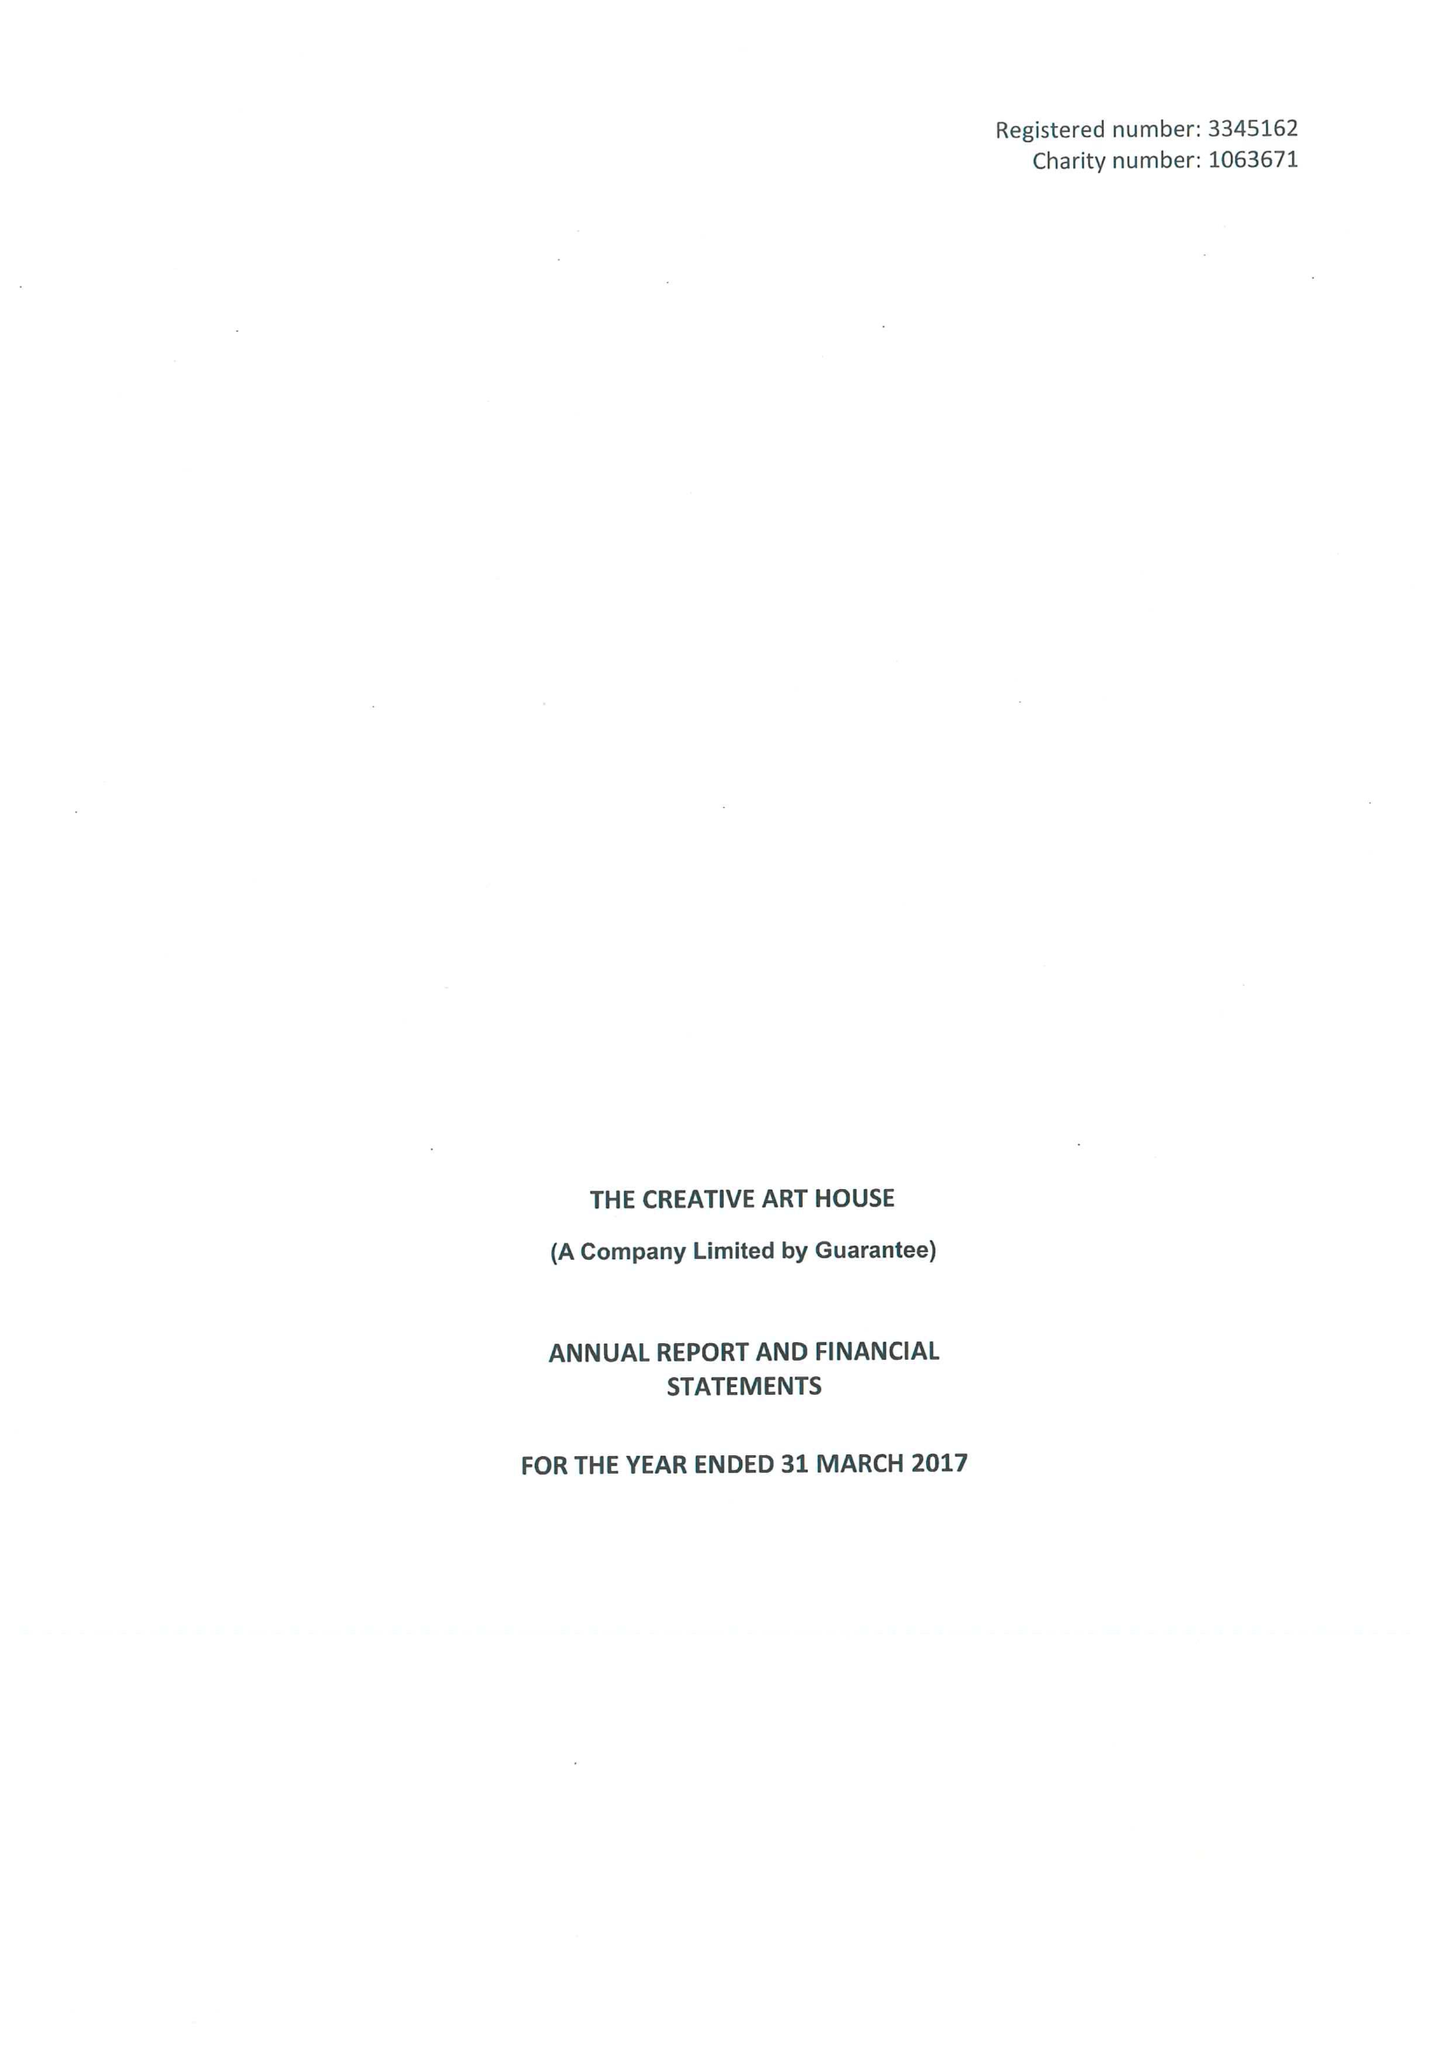What is the value for the report_date?
Answer the question using a single word or phrase. 2017-03-31 